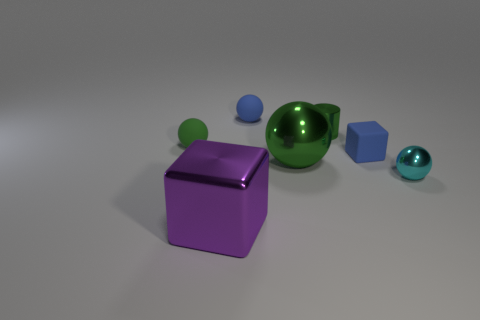Subtract 1 balls. How many balls are left? 3 Add 2 small blue objects. How many objects exist? 9 Subtract all cubes. How many objects are left? 5 Add 2 tiny cubes. How many tiny cubes are left? 3 Add 6 big yellow metal cylinders. How many big yellow metal cylinders exist? 6 Subtract 0 cyan cylinders. How many objects are left? 7 Subtract all purple shiny things. Subtract all blue spheres. How many objects are left? 5 